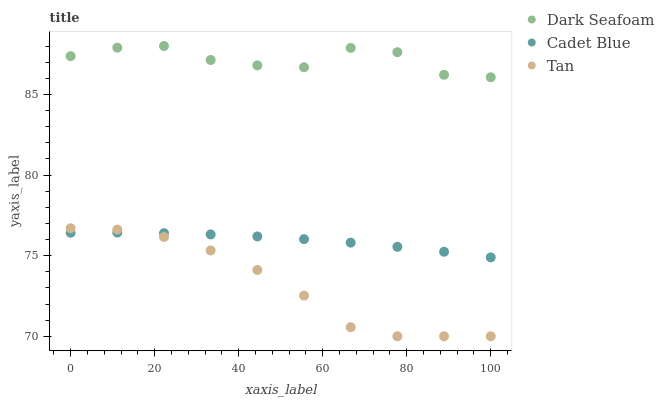Does Tan have the minimum area under the curve?
Answer yes or no. Yes. Does Dark Seafoam have the maximum area under the curve?
Answer yes or no. Yes. Does Cadet Blue have the minimum area under the curve?
Answer yes or no. No. Does Cadet Blue have the maximum area under the curve?
Answer yes or no. No. Is Cadet Blue the smoothest?
Answer yes or no. Yes. Is Dark Seafoam the roughest?
Answer yes or no. Yes. Is Tan the smoothest?
Answer yes or no. No. Is Tan the roughest?
Answer yes or no. No. Does Tan have the lowest value?
Answer yes or no. Yes. Does Cadet Blue have the lowest value?
Answer yes or no. No. Does Dark Seafoam have the highest value?
Answer yes or no. Yes. Does Tan have the highest value?
Answer yes or no. No. Is Tan less than Dark Seafoam?
Answer yes or no. Yes. Is Dark Seafoam greater than Tan?
Answer yes or no. Yes. Does Cadet Blue intersect Tan?
Answer yes or no. Yes. Is Cadet Blue less than Tan?
Answer yes or no. No. Is Cadet Blue greater than Tan?
Answer yes or no. No. Does Tan intersect Dark Seafoam?
Answer yes or no. No. 